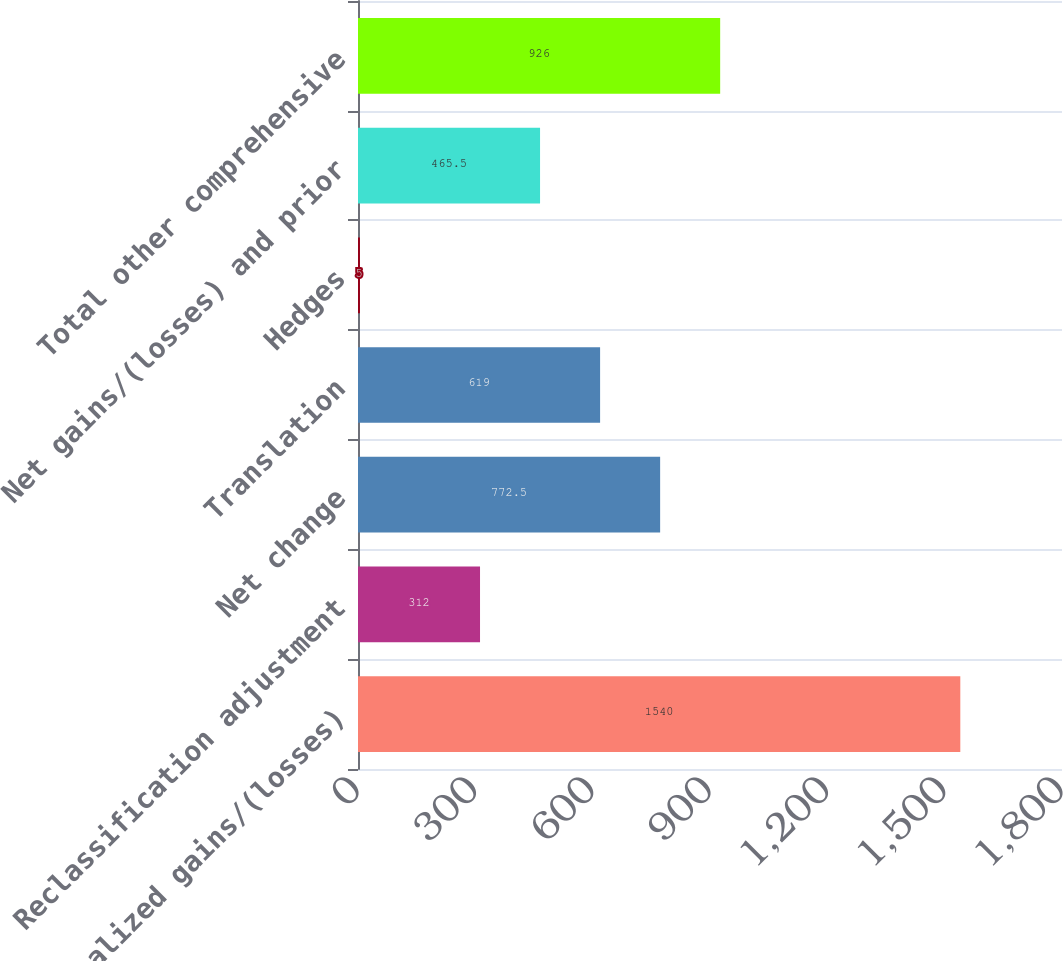Convert chart. <chart><loc_0><loc_0><loc_500><loc_500><bar_chart><fcel>Net unrealized gains/(losses)<fcel>Reclassification adjustment<fcel>Net change<fcel>Translation<fcel>Hedges<fcel>Net gains/(losses) and prior<fcel>Total other comprehensive<nl><fcel>1540<fcel>312<fcel>772.5<fcel>619<fcel>5<fcel>465.5<fcel>926<nl></chart> 